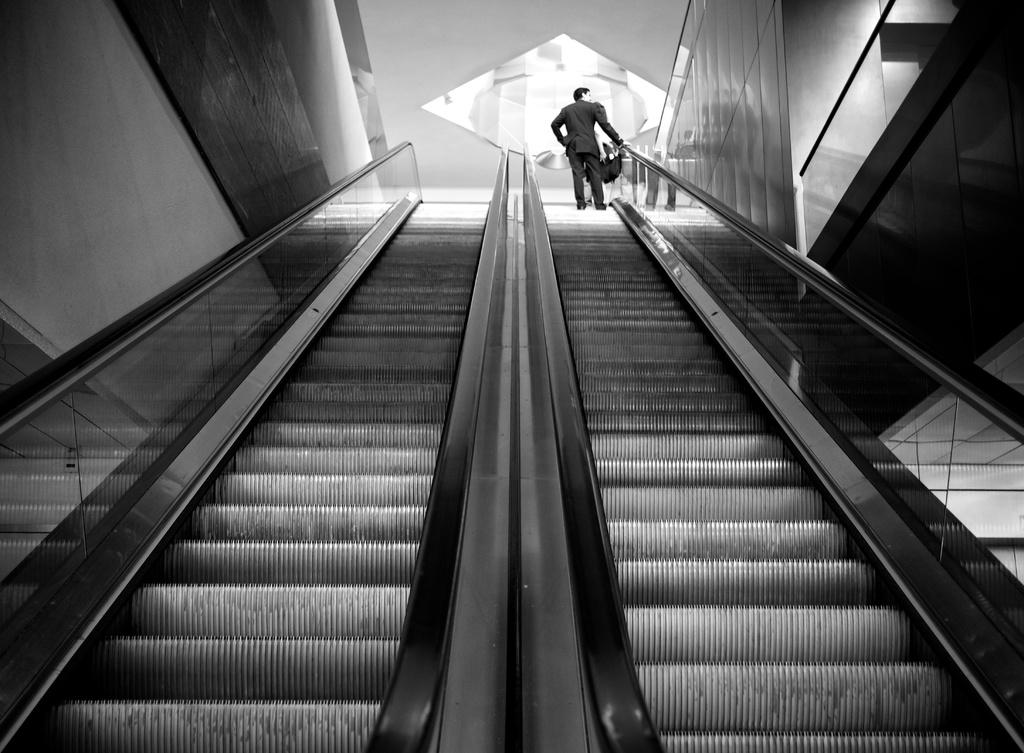Who is the main subject in the image? There is a man in the image. What is the man doing in the image? The man is standing on an escalator. What is the color scheme of the image? The image is in black and white color. What type of skirt is the governor wearing in the image? There is no governor or skirt present in the image. 